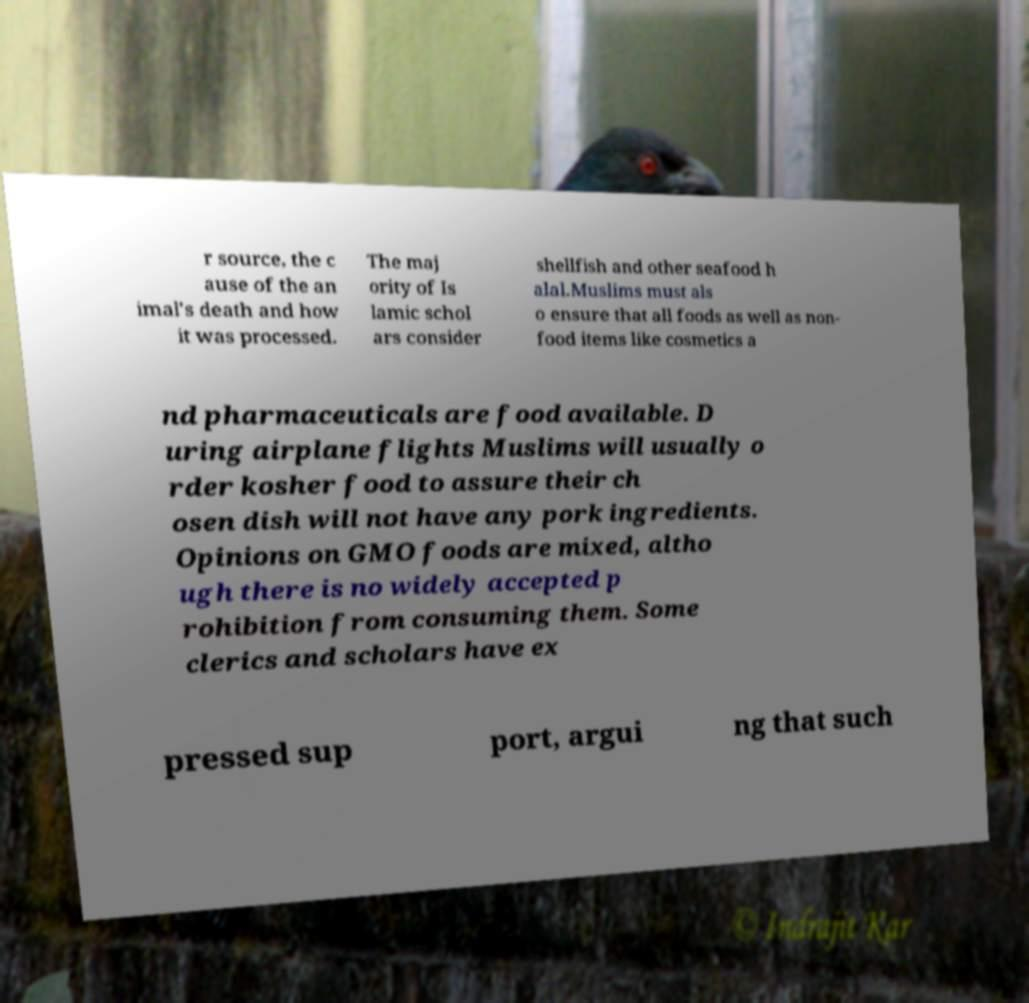There's text embedded in this image that I need extracted. Can you transcribe it verbatim? r source, the c ause of the an imal's death and how it was processed. The maj ority of Is lamic schol ars consider shellfish and other seafood h alal.Muslims must als o ensure that all foods as well as non- food items like cosmetics a nd pharmaceuticals are food available. D uring airplane flights Muslims will usually o rder kosher food to assure their ch osen dish will not have any pork ingredients. Opinions on GMO foods are mixed, altho ugh there is no widely accepted p rohibition from consuming them. Some clerics and scholars have ex pressed sup port, argui ng that such 